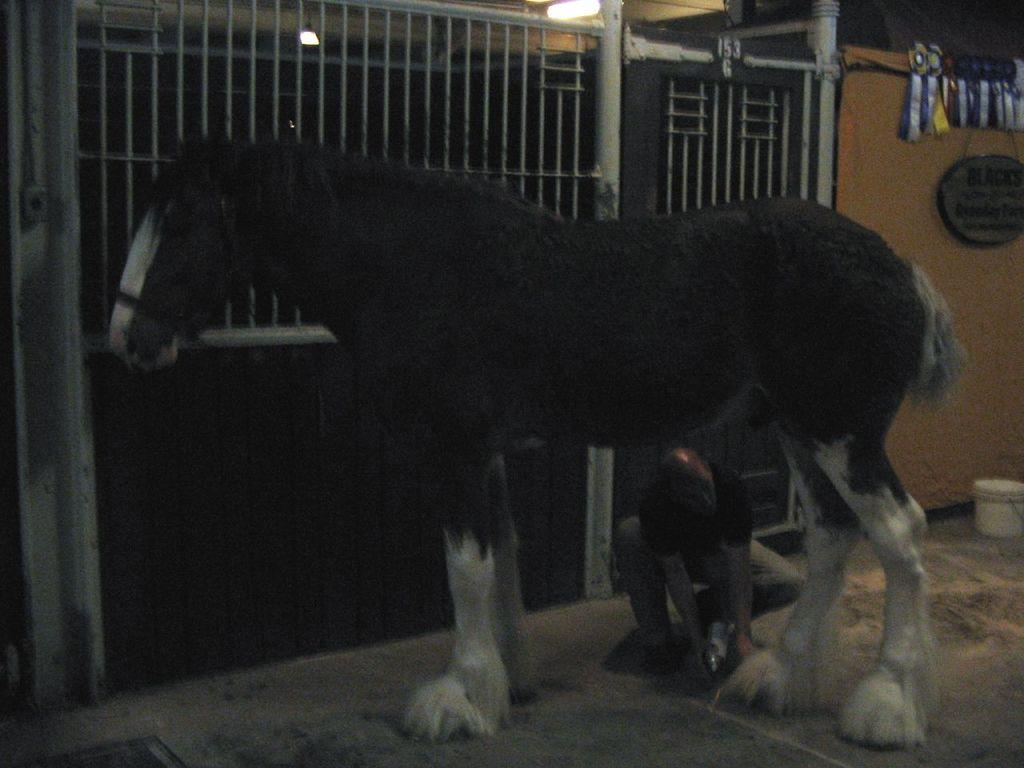What type of animal is in the image? There is a black horse in the image. What is the man doing in relation to the horse? The man is in a squat position under the horse. What objects with designs can be seen in the image? There are badges in the image. What can be seen providing illumination in the image? There are lights in the image. Is there a cushion on the horse's back in the image? No, there is no cushion on the horse's back in the image. What is the horse's temper like in the image? The horse's temper cannot be determined from the image, as it only shows the horse and the man in a squat position under it. 